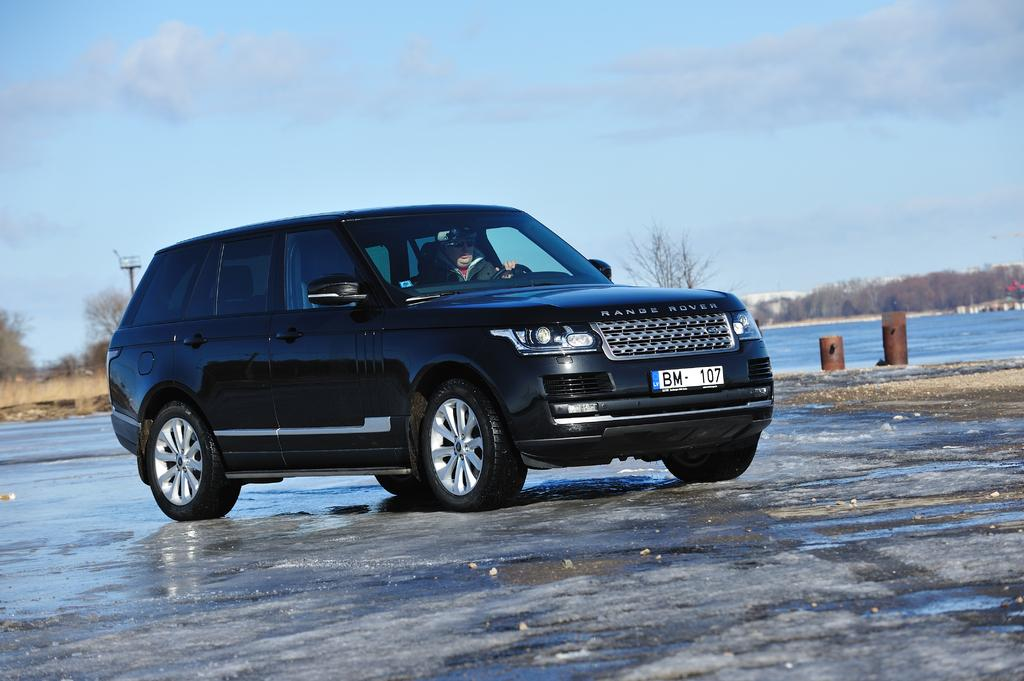What is the main subject of the image? There is a black color car in the center of the image. What can be seen in the background of the image? There is water and trees in the background of the image. What type of crayon is being used to draw on the car in the image? There is no crayon or drawing on the car in the image; it is a black color car with no additional markings. 